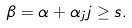Convert formula to latex. <formula><loc_0><loc_0><loc_500><loc_500>\beta = \alpha + \alpha _ { j } j \geq s .</formula> 